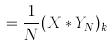Convert formula to latex. <formula><loc_0><loc_0><loc_500><loc_500>= \frac { 1 } { N } ( X * Y _ { N } ) _ { k }</formula> 